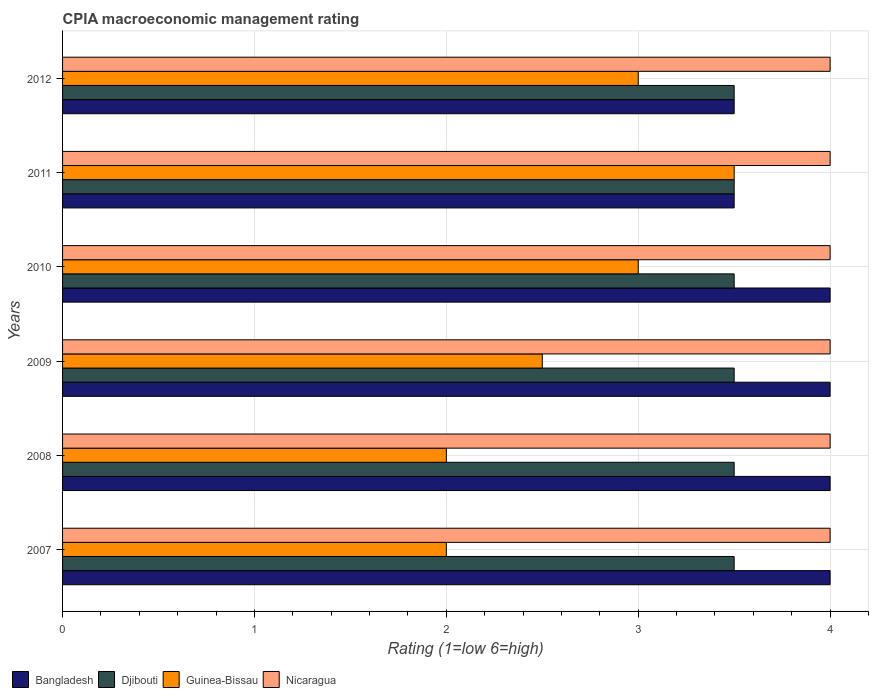How many different coloured bars are there?
Your response must be concise. 4. How many groups of bars are there?
Offer a very short reply. 6. How many bars are there on the 4th tick from the top?
Give a very brief answer. 4. How many bars are there on the 3rd tick from the bottom?
Your response must be concise. 4. Across all years, what is the maximum CPIA rating in Bangladesh?
Make the answer very short. 4. In which year was the CPIA rating in Nicaragua maximum?
Ensure brevity in your answer.  2007. In which year was the CPIA rating in Guinea-Bissau minimum?
Make the answer very short. 2007. What is the total CPIA rating in Guinea-Bissau in the graph?
Give a very brief answer. 16. What is the difference between the CPIA rating in Bangladesh in 2007 and that in 2012?
Provide a succinct answer. 0.5. What is the average CPIA rating in Bangladesh per year?
Provide a succinct answer. 3.83. In the year 2009, what is the difference between the CPIA rating in Guinea-Bissau and CPIA rating in Nicaragua?
Keep it short and to the point. -1.5. In how many years, is the CPIA rating in Djibouti greater than 1 ?
Give a very brief answer. 6. What is the ratio of the CPIA rating in Guinea-Bissau in 2009 to that in 2012?
Provide a short and direct response. 0.83. What is the difference between the highest and the second highest CPIA rating in Djibouti?
Your answer should be very brief. 0. What is the difference between the highest and the lowest CPIA rating in Bangladesh?
Your answer should be compact. 0.5. In how many years, is the CPIA rating in Bangladesh greater than the average CPIA rating in Bangladesh taken over all years?
Your response must be concise. 4. What does the 2nd bar from the top in 2010 represents?
Provide a short and direct response. Guinea-Bissau. What does the 4th bar from the bottom in 2010 represents?
Keep it short and to the point. Nicaragua. Is it the case that in every year, the sum of the CPIA rating in Djibouti and CPIA rating in Bangladesh is greater than the CPIA rating in Guinea-Bissau?
Keep it short and to the point. Yes. Are all the bars in the graph horizontal?
Provide a succinct answer. Yes. How many years are there in the graph?
Ensure brevity in your answer.  6. What is the difference between two consecutive major ticks on the X-axis?
Offer a terse response. 1. Are the values on the major ticks of X-axis written in scientific E-notation?
Ensure brevity in your answer.  No. Does the graph contain grids?
Your answer should be compact. Yes. Where does the legend appear in the graph?
Your answer should be compact. Bottom left. How many legend labels are there?
Your answer should be very brief. 4. How are the legend labels stacked?
Provide a succinct answer. Horizontal. What is the title of the graph?
Keep it short and to the point. CPIA macroeconomic management rating. Does "Moldova" appear as one of the legend labels in the graph?
Give a very brief answer. No. What is the label or title of the X-axis?
Provide a succinct answer. Rating (1=low 6=high). What is the label or title of the Y-axis?
Offer a very short reply. Years. What is the Rating (1=low 6=high) in Guinea-Bissau in 2007?
Keep it short and to the point. 2. What is the Rating (1=low 6=high) of Bangladesh in 2008?
Make the answer very short. 4. What is the Rating (1=low 6=high) in Djibouti in 2008?
Your response must be concise. 3.5. What is the Rating (1=low 6=high) in Bangladesh in 2009?
Provide a succinct answer. 4. What is the Rating (1=low 6=high) in Djibouti in 2009?
Ensure brevity in your answer.  3.5. What is the Rating (1=low 6=high) in Djibouti in 2010?
Offer a terse response. 3.5. What is the Rating (1=low 6=high) of Guinea-Bissau in 2010?
Your answer should be very brief. 3. What is the Rating (1=low 6=high) in Djibouti in 2011?
Ensure brevity in your answer.  3.5. What is the Rating (1=low 6=high) in Guinea-Bissau in 2011?
Make the answer very short. 3.5. Across all years, what is the maximum Rating (1=low 6=high) in Bangladesh?
Give a very brief answer. 4. Across all years, what is the maximum Rating (1=low 6=high) of Guinea-Bissau?
Keep it short and to the point. 3.5. Across all years, what is the maximum Rating (1=low 6=high) of Nicaragua?
Offer a very short reply. 4. Across all years, what is the minimum Rating (1=low 6=high) in Djibouti?
Provide a succinct answer. 3.5. Across all years, what is the minimum Rating (1=low 6=high) in Guinea-Bissau?
Offer a very short reply. 2. Across all years, what is the minimum Rating (1=low 6=high) of Nicaragua?
Keep it short and to the point. 4. What is the total Rating (1=low 6=high) in Bangladesh in the graph?
Your response must be concise. 23. What is the total Rating (1=low 6=high) of Djibouti in the graph?
Your answer should be very brief. 21. What is the total Rating (1=low 6=high) in Nicaragua in the graph?
Keep it short and to the point. 24. What is the difference between the Rating (1=low 6=high) of Djibouti in 2007 and that in 2008?
Keep it short and to the point. 0. What is the difference between the Rating (1=low 6=high) of Guinea-Bissau in 2007 and that in 2008?
Ensure brevity in your answer.  0. What is the difference between the Rating (1=low 6=high) in Bangladesh in 2007 and that in 2009?
Ensure brevity in your answer.  0. What is the difference between the Rating (1=low 6=high) in Djibouti in 2007 and that in 2009?
Offer a very short reply. 0. What is the difference between the Rating (1=low 6=high) in Guinea-Bissau in 2007 and that in 2010?
Keep it short and to the point. -1. What is the difference between the Rating (1=low 6=high) in Nicaragua in 2007 and that in 2010?
Offer a very short reply. 0. What is the difference between the Rating (1=low 6=high) in Bangladesh in 2007 and that in 2011?
Ensure brevity in your answer.  0.5. What is the difference between the Rating (1=low 6=high) of Guinea-Bissau in 2007 and that in 2011?
Ensure brevity in your answer.  -1.5. What is the difference between the Rating (1=low 6=high) of Nicaragua in 2007 and that in 2011?
Your answer should be compact. 0. What is the difference between the Rating (1=low 6=high) in Djibouti in 2007 and that in 2012?
Make the answer very short. 0. What is the difference between the Rating (1=low 6=high) in Guinea-Bissau in 2007 and that in 2012?
Offer a very short reply. -1. What is the difference between the Rating (1=low 6=high) in Bangladesh in 2008 and that in 2009?
Ensure brevity in your answer.  0. What is the difference between the Rating (1=low 6=high) of Djibouti in 2008 and that in 2009?
Make the answer very short. 0. What is the difference between the Rating (1=low 6=high) in Guinea-Bissau in 2008 and that in 2009?
Offer a very short reply. -0.5. What is the difference between the Rating (1=low 6=high) of Nicaragua in 2008 and that in 2009?
Make the answer very short. 0. What is the difference between the Rating (1=low 6=high) of Djibouti in 2008 and that in 2010?
Make the answer very short. 0. What is the difference between the Rating (1=low 6=high) in Nicaragua in 2008 and that in 2010?
Keep it short and to the point. 0. What is the difference between the Rating (1=low 6=high) of Djibouti in 2008 and that in 2011?
Offer a terse response. 0. What is the difference between the Rating (1=low 6=high) of Guinea-Bissau in 2008 and that in 2011?
Provide a short and direct response. -1.5. What is the difference between the Rating (1=low 6=high) of Nicaragua in 2008 and that in 2011?
Offer a very short reply. 0. What is the difference between the Rating (1=low 6=high) in Bangladesh in 2008 and that in 2012?
Offer a very short reply. 0.5. What is the difference between the Rating (1=low 6=high) in Guinea-Bissau in 2008 and that in 2012?
Ensure brevity in your answer.  -1. What is the difference between the Rating (1=low 6=high) in Bangladesh in 2009 and that in 2010?
Ensure brevity in your answer.  0. What is the difference between the Rating (1=low 6=high) of Guinea-Bissau in 2009 and that in 2010?
Offer a terse response. -0.5. What is the difference between the Rating (1=low 6=high) of Bangladesh in 2009 and that in 2011?
Offer a very short reply. 0.5. What is the difference between the Rating (1=low 6=high) in Djibouti in 2009 and that in 2011?
Provide a succinct answer. 0. What is the difference between the Rating (1=low 6=high) of Guinea-Bissau in 2009 and that in 2011?
Provide a succinct answer. -1. What is the difference between the Rating (1=low 6=high) of Djibouti in 2010 and that in 2012?
Keep it short and to the point. 0. What is the difference between the Rating (1=low 6=high) of Nicaragua in 2010 and that in 2012?
Give a very brief answer. 0. What is the difference between the Rating (1=low 6=high) in Bangladesh in 2011 and that in 2012?
Give a very brief answer. 0. What is the difference between the Rating (1=low 6=high) of Djibouti in 2011 and that in 2012?
Your answer should be compact. 0. What is the difference between the Rating (1=low 6=high) in Guinea-Bissau in 2011 and that in 2012?
Your response must be concise. 0.5. What is the difference between the Rating (1=low 6=high) of Nicaragua in 2011 and that in 2012?
Your answer should be very brief. 0. What is the difference between the Rating (1=low 6=high) of Bangladesh in 2007 and the Rating (1=low 6=high) of Djibouti in 2008?
Provide a succinct answer. 0.5. What is the difference between the Rating (1=low 6=high) of Bangladesh in 2007 and the Rating (1=low 6=high) of Nicaragua in 2008?
Make the answer very short. 0. What is the difference between the Rating (1=low 6=high) of Djibouti in 2007 and the Rating (1=low 6=high) of Guinea-Bissau in 2008?
Give a very brief answer. 1.5. What is the difference between the Rating (1=low 6=high) in Guinea-Bissau in 2007 and the Rating (1=low 6=high) in Nicaragua in 2008?
Give a very brief answer. -2. What is the difference between the Rating (1=low 6=high) in Bangladesh in 2007 and the Rating (1=low 6=high) in Guinea-Bissau in 2009?
Provide a short and direct response. 1.5. What is the difference between the Rating (1=low 6=high) of Bangladesh in 2007 and the Rating (1=low 6=high) of Nicaragua in 2009?
Your response must be concise. 0. What is the difference between the Rating (1=low 6=high) of Bangladesh in 2007 and the Rating (1=low 6=high) of Guinea-Bissau in 2010?
Provide a succinct answer. 1. What is the difference between the Rating (1=low 6=high) in Bangladesh in 2007 and the Rating (1=low 6=high) in Nicaragua in 2010?
Offer a very short reply. 0. What is the difference between the Rating (1=low 6=high) in Djibouti in 2007 and the Rating (1=low 6=high) in Guinea-Bissau in 2010?
Your response must be concise. 0.5. What is the difference between the Rating (1=low 6=high) of Djibouti in 2007 and the Rating (1=low 6=high) of Nicaragua in 2010?
Offer a very short reply. -0.5. What is the difference between the Rating (1=low 6=high) in Guinea-Bissau in 2007 and the Rating (1=low 6=high) in Nicaragua in 2010?
Provide a succinct answer. -2. What is the difference between the Rating (1=low 6=high) of Bangladesh in 2007 and the Rating (1=low 6=high) of Djibouti in 2011?
Keep it short and to the point. 0.5. What is the difference between the Rating (1=low 6=high) of Bangladesh in 2007 and the Rating (1=low 6=high) of Guinea-Bissau in 2011?
Your response must be concise. 0.5. What is the difference between the Rating (1=low 6=high) in Bangladesh in 2007 and the Rating (1=low 6=high) in Nicaragua in 2011?
Ensure brevity in your answer.  0. What is the difference between the Rating (1=low 6=high) of Djibouti in 2007 and the Rating (1=low 6=high) of Nicaragua in 2011?
Offer a terse response. -0.5. What is the difference between the Rating (1=low 6=high) of Guinea-Bissau in 2007 and the Rating (1=low 6=high) of Nicaragua in 2011?
Offer a very short reply. -2. What is the difference between the Rating (1=low 6=high) of Bangladesh in 2007 and the Rating (1=low 6=high) of Djibouti in 2012?
Ensure brevity in your answer.  0.5. What is the difference between the Rating (1=low 6=high) in Bangladesh in 2007 and the Rating (1=low 6=high) in Guinea-Bissau in 2012?
Offer a very short reply. 1. What is the difference between the Rating (1=low 6=high) of Djibouti in 2007 and the Rating (1=low 6=high) of Nicaragua in 2012?
Your answer should be compact. -0.5. What is the difference between the Rating (1=low 6=high) of Guinea-Bissau in 2007 and the Rating (1=low 6=high) of Nicaragua in 2012?
Give a very brief answer. -2. What is the difference between the Rating (1=low 6=high) of Bangladesh in 2008 and the Rating (1=low 6=high) of Djibouti in 2009?
Offer a very short reply. 0.5. What is the difference between the Rating (1=low 6=high) of Bangladesh in 2008 and the Rating (1=low 6=high) of Nicaragua in 2009?
Your answer should be very brief. 0. What is the difference between the Rating (1=low 6=high) in Djibouti in 2008 and the Rating (1=low 6=high) in Guinea-Bissau in 2009?
Provide a short and direct response. 1. What is the difference between the Rating (1=low 6=high) of Guinea-Bissau in 2008 and the Rating (1=low 6=high) of Nicaragua in 2009?
Make the answer very short. -2. What is the difference between the Rating (1=low 6=high) of Bangladesh in 2008 and the Rating (1=low 6=high) of Djibouti in 2010?
Provide a short and direct response. 0.5. What is the difference between the Rating (1=low 6=high) of Bangladesh in 2008 and the Rating (1=low 6=high) of Guinea-Bissau in 2010?
Your response must be concise. 1. What is the difference between the Rating (1=low 6=high) of Bangladesh in 2008 and the Rating (1=low 6=high) of Nicaragua in 2010?
Provide a short and direct response. 0. What is the difference between the Rating (1=low 6=high) of Djibouti in 2008 and the Rating (1=low 6=high) of Guinea-Bissau in 2010?
Your answer should be compact. 0.5. What is the difference between the Rating (1=low 6=high) of Bangladesh in 2008 and the Rating (1=low 6=high) of Djibouti in 2011?
Provide a succinct answer. 0.5. What is the difference between the Rating (1=low 6=high) of Bangladesh in 2008 and the Rating (1=low 6=high) of Guinea-Bissau in 2011?
Make the answer very short. 0.5. What is the difference between the Rating (1=low 6=high) in Djibouti in 2008 and the Rating (1=low 6=high) in Guinea-Bissau in 2011?
Your response must be concise. 0. What is the difference between the Rating (1=low 6=high) of Guinea-Bissau in 2008 and the Rating (1=low 6=high) of Nicaragua in 2011?
Your answer should be compact. -2. What is the difference between the Rating (1=low 6=high) in Bangladesh in 2008 and the Rating (1=low 6=high) in Guinea-Bissau in 2012?
Your answer should be very brief. 1. What is the difference between the Rating (1=low 6=high) of Bangladesh in 2008 and the Rating (1=low 6=high) of Nicaragua in 2012?
Ensure brevity in your answer.  0. What is the difference between the Rating (1=low 6=high) of Guinea-Bissau in 2008 and the Rating (1=low 6=high) of Nicaragua in 2012?
Your response must be concise. -2. What is the difference between the Rating (1=low 6=high) of Bangladesh in 2009 and the Rating (1=low 6=high) of Guinea-Bissau in 2010?
Make the answer very short. 1. What is the difference between the Rating (1=low 6=high) of Bangladesh in 2009 and the Rating (1=low 6=high) of Nicaragua in 2010?
Offer a very short reply. 0. What is the difference between the Rating (1=low 6=high) in Djibouti in 2009 and the Rating (1=low 6=high) in Guinea-Bissau in 2010?
Ensure brevity in your answer.  0.5. What is the difference between the Rating (1=low 6=high) in Bangladesh in 2009 and the Rating (1=low 6=high) in Djibouti in 2011?
Make the answer very short. 0.5. What is the difference between the Rating (1=low 6=high) of Djibouti in 2009 and the Rating (1=low 6=high) of Nicaragua in 2011?
Your response must be concise. -0.5. What is the difference between the Rating (1=low 6=high) of Guinea-Bissau in 2009 and the Rating (1=low 6=high) of Nicaragua in 2011?
Ensure brevity in your answer.  -1.5. What is the difference between the Rating (1=low 6=high) in Bangladesh in 2009 and the Rating (1=low 6=high) in Djibouti in 2012?
Your answer should be very brief. 0.5. What is the difference between the Rating (1=low 6=high) of Bangladesh in 2009 and the Rating (1=low 6=high) of Nicaragua in 2012?
Your response must be concise. 0. What is the difference between the Rating (1=low 6=high) of Guinea-Bissau in 2009 and the Rating (1=low 6=high) of Nicaragua in 2012?
Offer a terse response. -1.5. What is the difference between the Rating (1=low 6=high) of Bangladesh in 2010 and the Rating (1=low 6=high) of Djibouti in 2011?
Your answer should be very brief. 0.5. What is the difference between the Rating (1=low 6=high) in Bangladesh in 2010 and the Rating (1=low 6=high) in Guinea-Bissau in 2011?
Make the answer very short. 0.5. What is the difference between the Rating (1=low 6=high) in Djibouti in 2010 and the Rating (1=low 6=high) in Guinea-Bissau in 2011?
Your answer should be very brief. 0. What is the difference between the Rating (1=low 6=high) in Djibouti in 2010 and the Rating (1=low 6=high) in Guinea-Bissau in 2012?
Your answer should be compact. 0.5. What is the difference between the Rating (1=low 6=high) of Djibouti in 2010 and the Rating (1=low 6=high) of Nicaragua in 2012?
Make the answer very short. -0.5. What is the difference between the Rating (1=low 6=high) in Guinea-Bissau in 2010 and the Rating (1=low 6=high) in Nicaragua in 2012?
Offer a terse response. -1. What is the difference between the Rating (1=low 6=high) in Djibouti in 2011 and the Rating (1=low 6=high) in Guinea-Bissau in 2012?
Keep it short and to the point. 0.5. What is the difference between the Rating (1=low 6=high) of Djibouti in 2011 and the Rating (1=low 6=high) of Nicaragua in 2012?
Provide a short and direct response. -0.5. What is the average Rating (1=low 6=high) of Bangladesh per year?
Provide a succinct answer. 3.83. What is the average Rating (1=low 6=high) of Guinea-Bissau per year?
Keep it short and to the point. 2.67. In the year 2007, what is the difference between the Rating (1=low 6=high) of Bangladesh and Rating (1=low 6=high) of Djibouti?
Provide a succinct answer. 0.5. In the year 2007, what is the difference between the Rating (1=low 6=high) of Bangladesh and Rating (1=low 6=high) of Guinea-Bissau?
Offer a very short reply. 2. In the year 2007, what is the difference between the Rating (1=low 6=high) of Djibouti and Rating (1=low 6=high) of Guinea-Bissau?
Your answer should be compact. 1.5. In the year 2007, what is the difference between the Rating (1=low 6=high) in Djibouti and Rating (1=low 6=high) in Nicaragua?
Your response must be concise. -0.5. In the year 2007, what is the difference between the Rating (1=low 6=high) in Guinea-Bissau and Rating (1=low 6=high) in Nicaragua?
Provide a succinct answer. -2. In the year 2008, what is the difference between the Rating (1=low 6=high) of Bangladesh and Rating (1=low 6=high) of Djibouti?
Offer a very short reply. 0.5. In the year 2008, what is the difference between the Rating (1=low 6=high) of Bangladesh and Rating (1=low 6=high) of Guinea-Bissau?
Provide a succinct answer. 2. In the year 2008, what is the difference between the Rating (1=low 6=high) of Djibouti and Rating (1=low 6=high) of Nicaragua?
Make the answer very short. -0.5. In the year 2008, what is the difference between the Rating (1=low 6=high) of Guinea-Bissau and Rating (1=low 6=high) of Nicaragua?
Give a very brief answer. -2. In the year 2009, what is the difference between the Rating (1=low 6=high) in Bangladesh and Rating (1=low 6=high) in Guinea-Bissau?
Your answer should be very brief. 1.5. In the year 2009, what is the difference between the Rating (1=low 6=high) of Djibouti and Rating (1=low 6=high) of Nicaragua?
Give a very brief answer. -0.5. In the year 2010, what is the difference between the Rating (1=low 6=high) in Djibouti and Rating (1=low 6=high) in Guinea-Bissau?
Ensure brevity in your answer.  0.5. In the year 2010, what is the difference between the Rating (1=low 6=high) in Guinea-Bissau and Rating (1=low 6=high) in Nicaragua?
Ensure brevity in your answer.  -1. In the year 2011, what is the difference between the Rating (1=low 6=high) of Bangladesh and Rating (1=low 6=high) of Guinea-Bissau?
Make the answer very short. 0. In the year 2011, what is the difference between the Rating (1=low 6=high) of Bangladesh and Rating (1=low 6=high) of Nicaragua?
Offer a terse response. -0.5. In the year 2011, what is the difference between the Rating (1=low 6=high) in Djibouti and Rating (1=low 6=high) in Guinea-Bissau?
Ensure brevity in your answer.  0. In the year 2012, what is the difference between the Rating (1=low 6=high) of Bangladesh and Rating (1=low 6=high) of Djibouti?
Offer a terse response. 0. In the year 2012, what is the difference between the Rating (1=low 6=high) of Bangladesh and Rating (1=low 6=high) of Guinea-Bissau?
Your response must be concise. 0.5. In the year 2012, what is the difference between the Rating (1=low 6=high) of Djibouti and Rating (1=low 6=high) of Nicaragua?
Your answer should be compact. -0.5. What is the ratio of the Rating (1=low 6=high) in Djibouti in 2007 to that in 2008?
Give a very brief answer. 1. What is the ratio of the Rating (1=low 6=high) in Nicaragua in 2007 to that in 2008?
Make the answer very short. 1. What is the ratio of the Rating (1=low 6=high) in Djibouti in 2007 to that in 2009?
Ensure brevity in your answer.  1. What is the ratio of the Rating (1=low 6=high) of Guinea-Bissau in 2007 to that in 2009?
Give a very brief answer. 0.8. What is the ratio of the Rating (1=low 6=high) of Nicaragua in 2007 to that in 2009?
Keep it short and to the point. 1. What is the ratio of the Rating (1=low 6=high) of Djibouti in 2007 to that in 2011?
Provide a succinct answer. 1. What is the ratio of the Rating (1=low 6=high) of Guinea-Bissau in 2007 to that in 2011?
Ensure brevity in your answer.  0.57. What is the ratio of the Rating (1=low 6=high) in Guinea-Bissau in 2007 to that in 2012?
Keep it short and to the point. 0.67. What is the ratio of the Rating (1=low 6=high) of Bangladesh in 2008 to that in 2009?
Provide a short and direct response. 1. What is the ratio of the Rating (1=low 6=high) in Djibouti in 2008 to that in 2009?
Provide a succinct answer. 1. What is the ratio of the Rating (1=low 6=high) in Guinea-Bissau in 2008 to that in 2009?
Make the answer very short. 0.8. What is the ratio of the Rating (1=low 6=high) in Nicaragua in 2008 to that in 2009?
Your response must be concise. 1. What is the ratio of the Rating (1=low 6=high) of Djibouti in 2008 to that in 2010?
Your answer should be very brief. 1. What is the ratio of the Rating (1=low 6=high) in Guinea-Bissau in 2008 to that in 2010?
Your answer should be compact. 0.67. What is the ratio of the Rating (1=low 6=high) of Djibouti in 2008 to that in 2011?
Your answer should be very brief. 1. What is the ratio of the Rating (1=low 6=high) in Djibouti in 2008 to that in 2012?
Give a very brief answer. 1. What is the ratio of the Rating (1=low 6=high) in Guinea-Bissau in 2008 to that in 2012?
Your answer should be very brief. 0.67. What is the ratio of the Rating (1=low 6=high) of Bangladesh in 2009 to that in 2010?
Ensure brevity in your answer.  1. What is the ratio of the Rating (1=low 6=high) of Djibouti in 2009 to that in 2010?
Your answer should be compact. 1. What is the ratio of the Rating (1=low 6=high) of Guinea-Bissau in 2009 to that in 2010?
Your answer should be compact. 0.83. What is the ratio of the Rating (1=low 6=high) in Guinea-Bissau in 2009 to that in 2011?
Ensure brevity in your answer.  0.71. What is the ratio of the Rating (1=low 6=high) in Bangladesh in 2009 to that in 2012?
Make the answer very short. 1.14. What is the ratio of the Rating (1=low 6=high) in Djibouti in 2009 to that in 2012?
Offer a terse response. 1. What is the ratio of the Rating (1=low 6=high) in Guinea-Bissau in 2009 to that in 2012?
Offer a very short reply. 0.83. What is the ratio of the Rating (1=low 6=high) of Nicaragua in 2009 to that in 2012?
Your response must be concise. 1. What is the ratio of the Rating (1=low 6=high) in Bangladesh in 2010 to that in 2011?
Your answer should be very brief. 1.14. What is the ratio of the Rating (1=low 6=high) of Djibouti in 2010 to that in 2011?
Ensure brevity in your answer.  1. What is the ratio of the Rating (1=low 6=high) of Guinea-Bissau in 2010 to that in 2011?
Give a very brief answer. 0.86. What is the ratio of the Rating (1=low 6=high) of Nicaragua in 2010 to that in 2011?
Offer a very short reply. 1. What is the ratio of the Rating (1=low 6=high) in Bangladesh in 2010 to that in 2012?
Make the answer very short. 1.14. What is the ratio of the Rating (1=low 6=high) in Guinea-Bissau in 2010 to that in 2012?
Give a very brief answer. 1. What is the ratio of the Rating (1=low 6=high) in Bangladesh in 2011 to that in 2012?
Provide a succinct answer. 1. What is the ratio of the Rating (1=low 6=high) of Djibouti in 2011 to that in 2012?
Your answer should be compact. 1. What is the ratio of the Rating (1=low 6=high) of Guinea-Bissau in 2011 to that in 2012?
Your answer should be compact. 1.17. What is the difference between the highest and the second highest Rating (1=low 6=high) of Nicaragua?
Your answer should be very brief. 0. What is the difference between the highest and the lowest Rating (1=low 6=high) of Bangladesh?
Your answer should be very brief. 0.5. What is the difference between the highest and the lowest Rating (1=low 6=high) in Djibouti?
Ensure brevity in your answer.  0. 